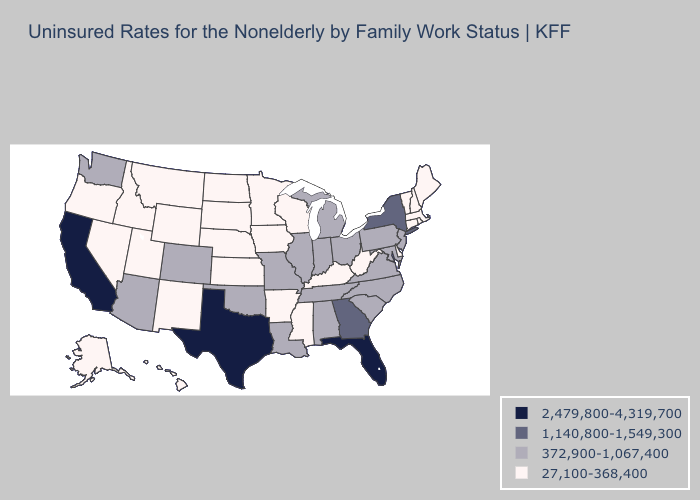What is the highest value in states that border South Dakota?
Write a very short answer. 27,100-368,400. Does Texas have the highest value in the USA?
Short answer required. Yes. Which states have the lowest value in the South?
Keep it brief. Arkansas, Delaware, Kentucky, Mississippi, West Virginia. What is the value of Michigan?
Answer briefly. 372,900-1,067,400. Does Nevada have the highest value in the West?
Keep it brief. No. Which states have the lowest value in the USA?
Keep it brief. Alaska, Arkansas, Connecticut, Delaware, Hawaii, Idaho, Iowa, Kansas, Kentucky, Maine, Massachusetts, Minnesota, Mississippi, Montana, Nebraska, Nevada, New Hampshire, New Mexico, North Dakota, Oregon, Rhode Island, South Dakota, Utah, Vermont, West Virginia, Wisconsin, Wyoming. Among the states that border Illinois , which have the highest value?
Keep it brief. Indiana, Missouri. Does the first symbol in the legend represent the smallest category?
Answer briefly. No. Which states hav the highest value in the Northeast?
Quick response, please. New York. Does Mississippi have a lower value than Texas?
Quick response, please. Yes. Name the states that have a value in the range 1,140,800-1,549,300?
Write a very short answer. Georgia, New York. Does North Dakota have the highest value in the USA?
Be succinct. No. What is the lowest value in states that border Maine?
Concise answer only. 27,100-368,400. Is the legend a continuous bar?
Keep it brief. No. 